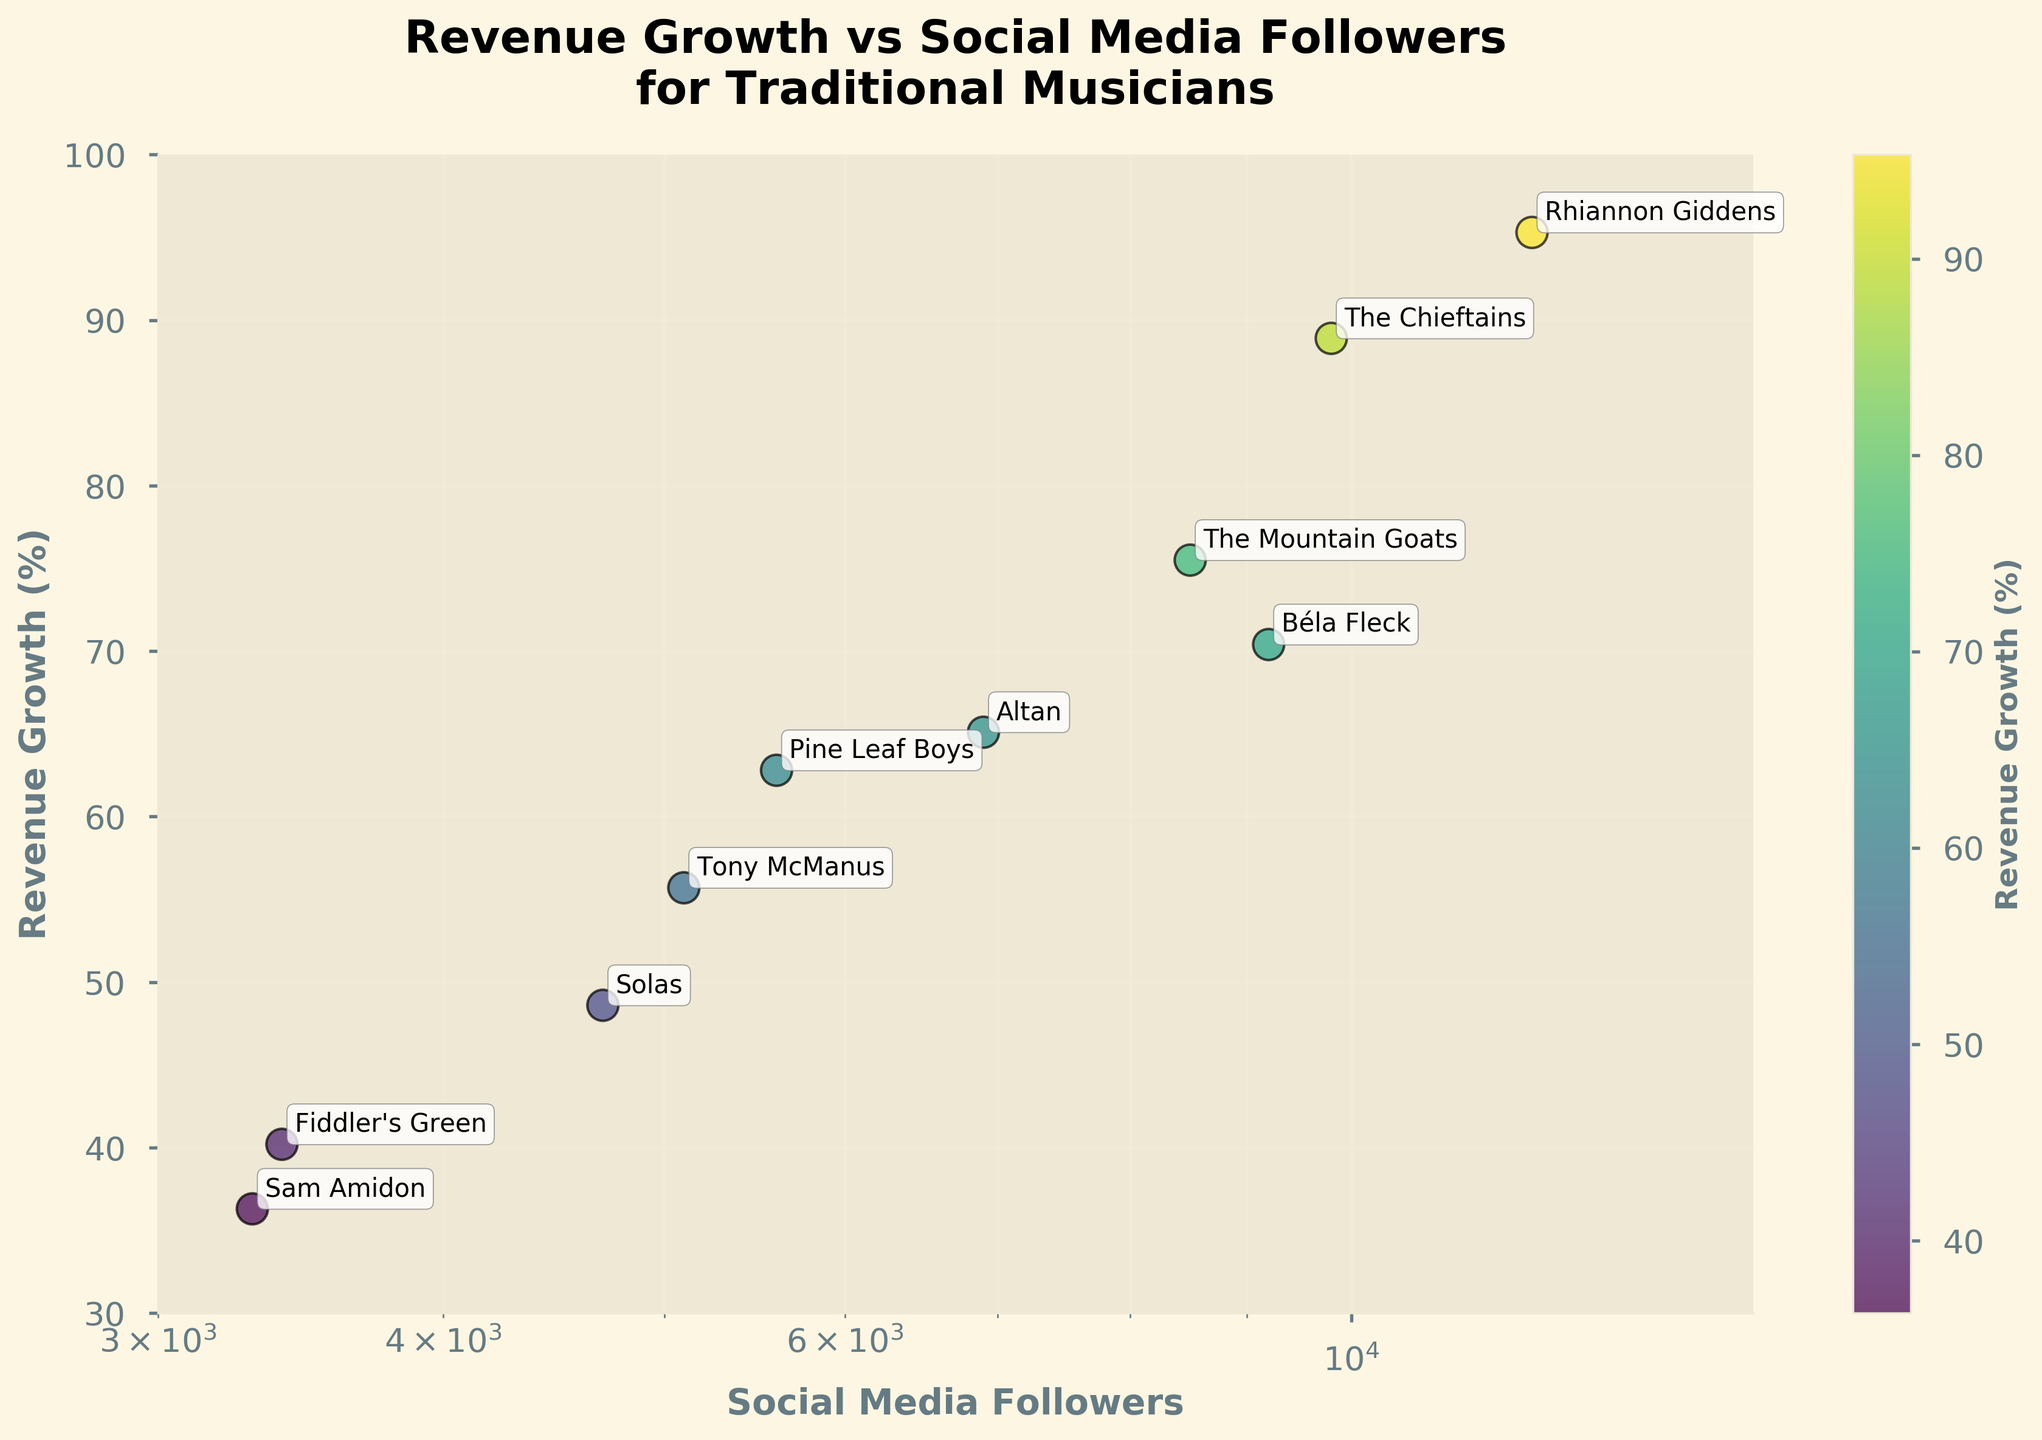What is the title of the scatter plot? The title of the scatter plot is clearly displayed at the top of the figure.
Answer: Revenue Growth vs Social Media Followers for Traditional Musicians What is the revenue growth percentage of 'Rhiannon Giddens'? Locate the point labeled 'Rhiannon Giddens' and read its corresponding y-axis value.
Answer: 95.3% How many musicians have more than 8000 social media followers? Look at the x-axis and count the points that are above 8000 on the x-scale.
Answer: 4 musicians Which musician has the lowest revenue growth percentage? Find the data point with the lowest y-axis value and read its label.
Answer: Sam Amidon What are the x-axis and y-axis labels of the scatter plot? The x-axis and y-axis labels are provided next to their respective axes.
Answer: Social Media Followers, Revenue Growth (%) What's the range of social media followers covered in the plot? Observe the limits set on the x-axis. The plot uses a log scale from 3000 to 15000.
Answer: 3000 to 15000 Is there a noticeable trend between social media followers and revenue growth? Visually inspect the scatter plot to see if there is a correlation or pattern between the two variables.
Answer: No clear trend Which musician has both a revenue growth above 80% and more than 9000 social media followers? Find points that meet both criteria: y-axis above 80% and x-axis above 9000, then read the labels.
Answer: The Chieftains, Rhiannon Giddens, Béla Fleck Compare the revenue growth of 'The Mountain Goats' and 'The Chieftains'. Who has higher revenue growth? Find the points labeled 'The Mountain Goats' and 'The Chieftains' and compare their y-axis values.
Answer: The Chieftains What is the color of the data point for 'Altan' and what does it signify? Identify 'Altan' and note its color. Use the color bar to interpret what this color represents regarding revenue growth.
Answer: Yellow-green, approx. 65.1% 